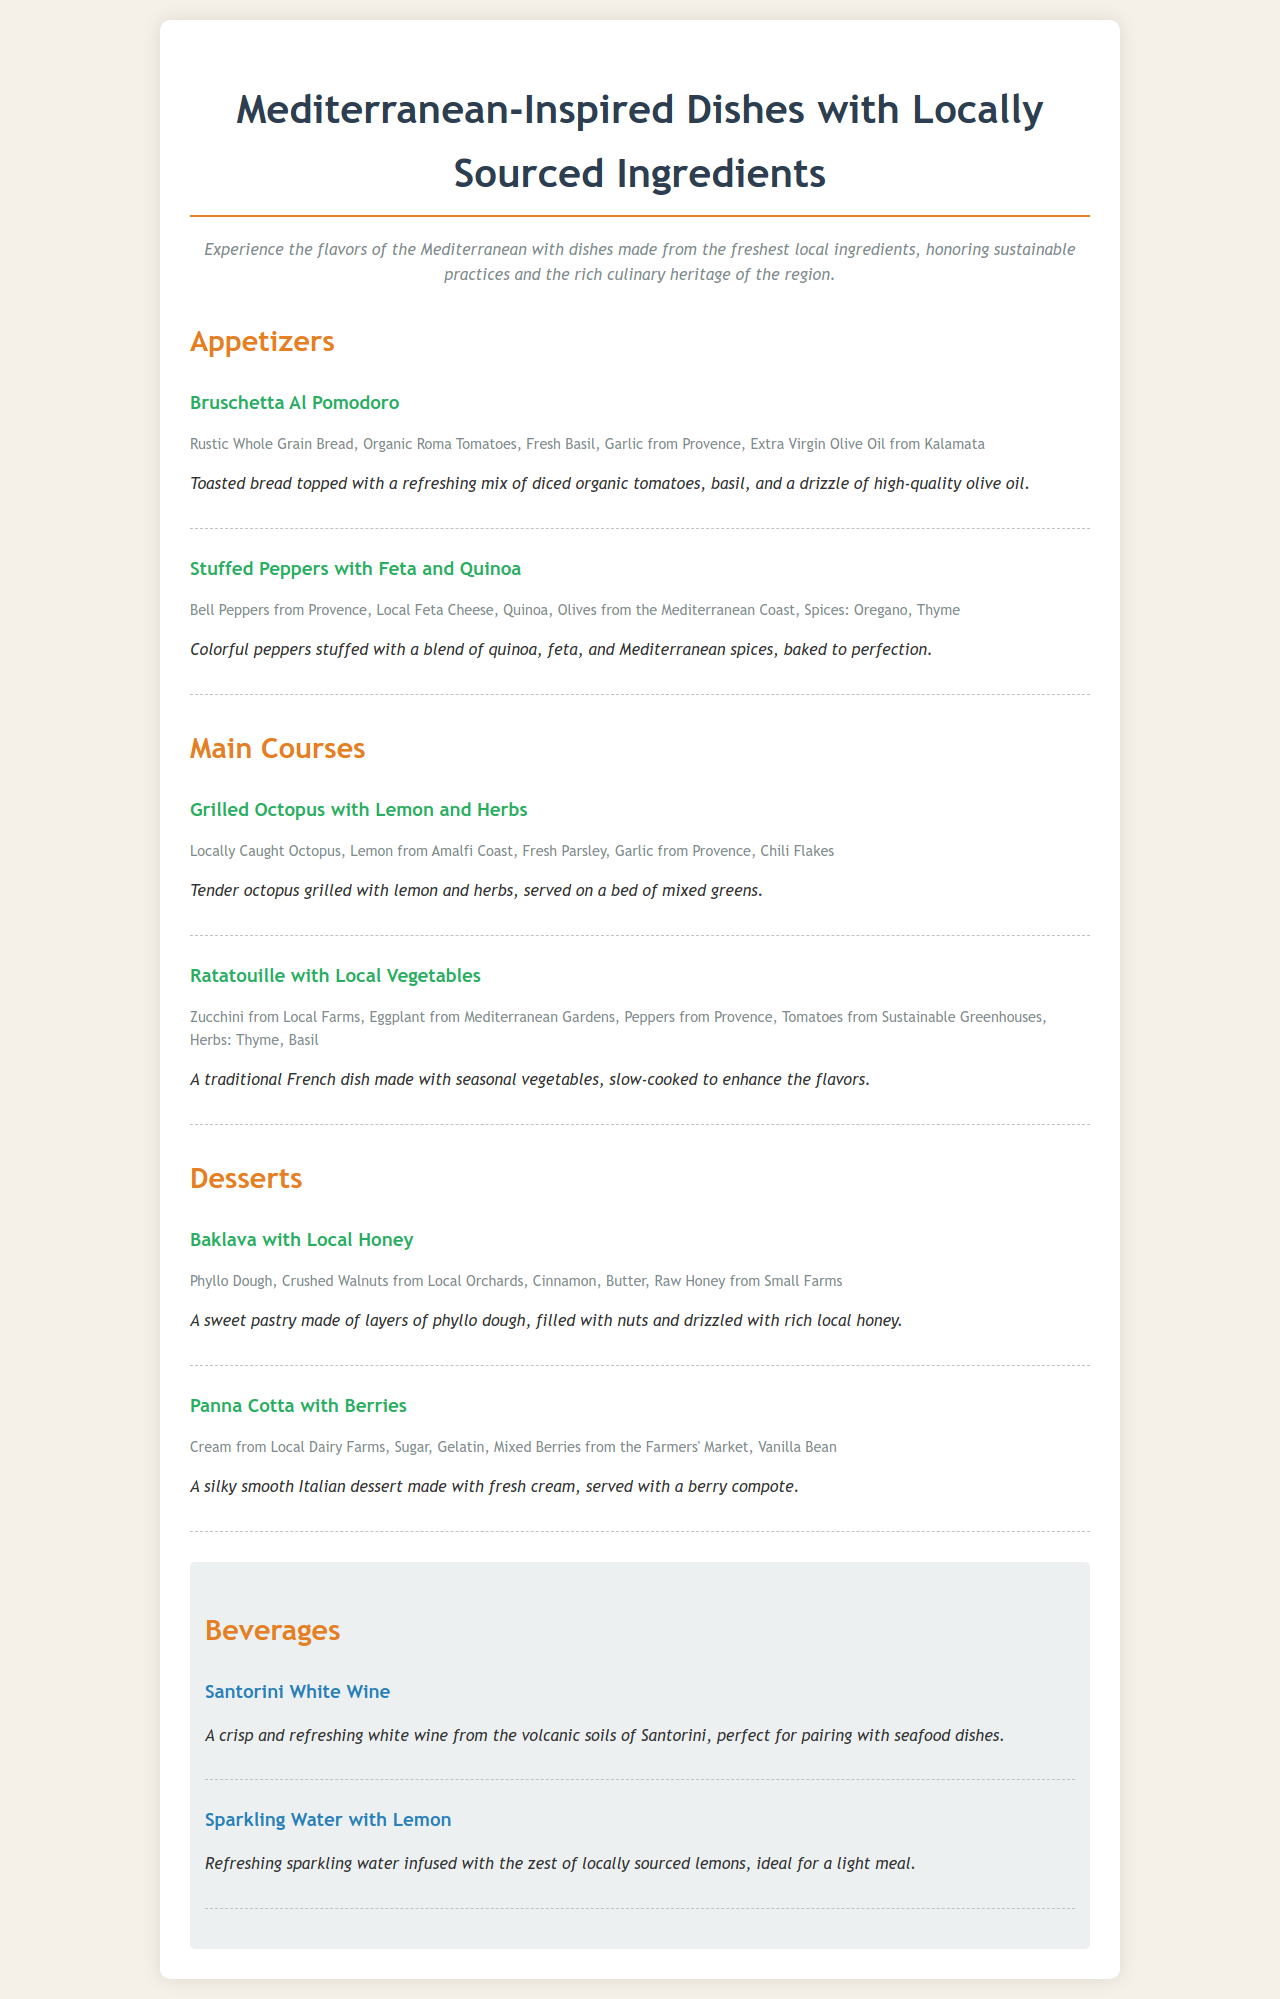What is the title of the menu? The title appears at the top of the document, indicating the type of cuisine offered.
Answer: Mediterranean-Inspired Dishes with Locally Sourced Ingredients Which ingredient is used in Bruschetta Al Pomodoro? The ingredient can be found in the listed items under Bruschetta Al Pomodoro in the menu.
Answer: Organic Roma Tomatoes What type of cheese is in the Stuffed Peppers? The type of cheese is explicitly stated in the ingredients for the Stuffed Peppers item.
Answer: Local Feta Cheese What is the main ingredient in Ratatouille? Ratatouille features one of its core ingredients in the title of the dish.
Answer: Local Vegetables How many desserts are listed in the menu? The total number of desserts can be calculated from the desserts section of the menu.
Answer: 2 What beverage pairs well with seafood? The beverage choice is specifically described in relation to pairing with seafood in the menu.
Answer: Santorini White Wine What cooking style is used for the Grilled Octopus? The cooking method is mentioned in the description of the Grilled Octopus dish.
Answer: Grilled Which ingredient gives Baklava its sweetness? The source of sweetness in Baklava is mentioned in the ingredient list.
Answer: Raw Honey from Small Farms What is the main flavor added to Sparkling Water? The flavor enhancement of Sparkling Water is stated in its description.
Answer: Lemon 